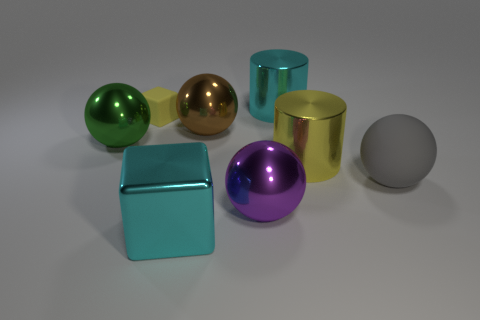There is a small object; does it have the same color as the large metal cylinder in front of the rubber block?
Your response must be concise. Yes. How many other things are there of the same color as the large block?
Provide a succinct answer. 1. Is there a metal cylinder that has the same size as the green object?
Give a very brief answer. Yes. There is a gray thing that is the same size as the yellow metallic cylinder; what is it made of?
Offer a terse response. Rubber. Are there any other things of the same shape as the gray rubber thing?
Provide a succinct answer. Yes. The cyan metal thing on the right side of the big purple shiny ball has what shape?
Provide a short and direct response. Cylinder. What number of small matte objects are there?
Offer a terse response. 1. The thing that is the same material as the yellow block is what color?
Offer a very short reply. Gray. What number of tiny objects are either purple balls or rubber objects?
Your answer should be compact. 1. How many shiny spheres are in front of the big brown shiny thing?
Provide a succinct answer. 2. 